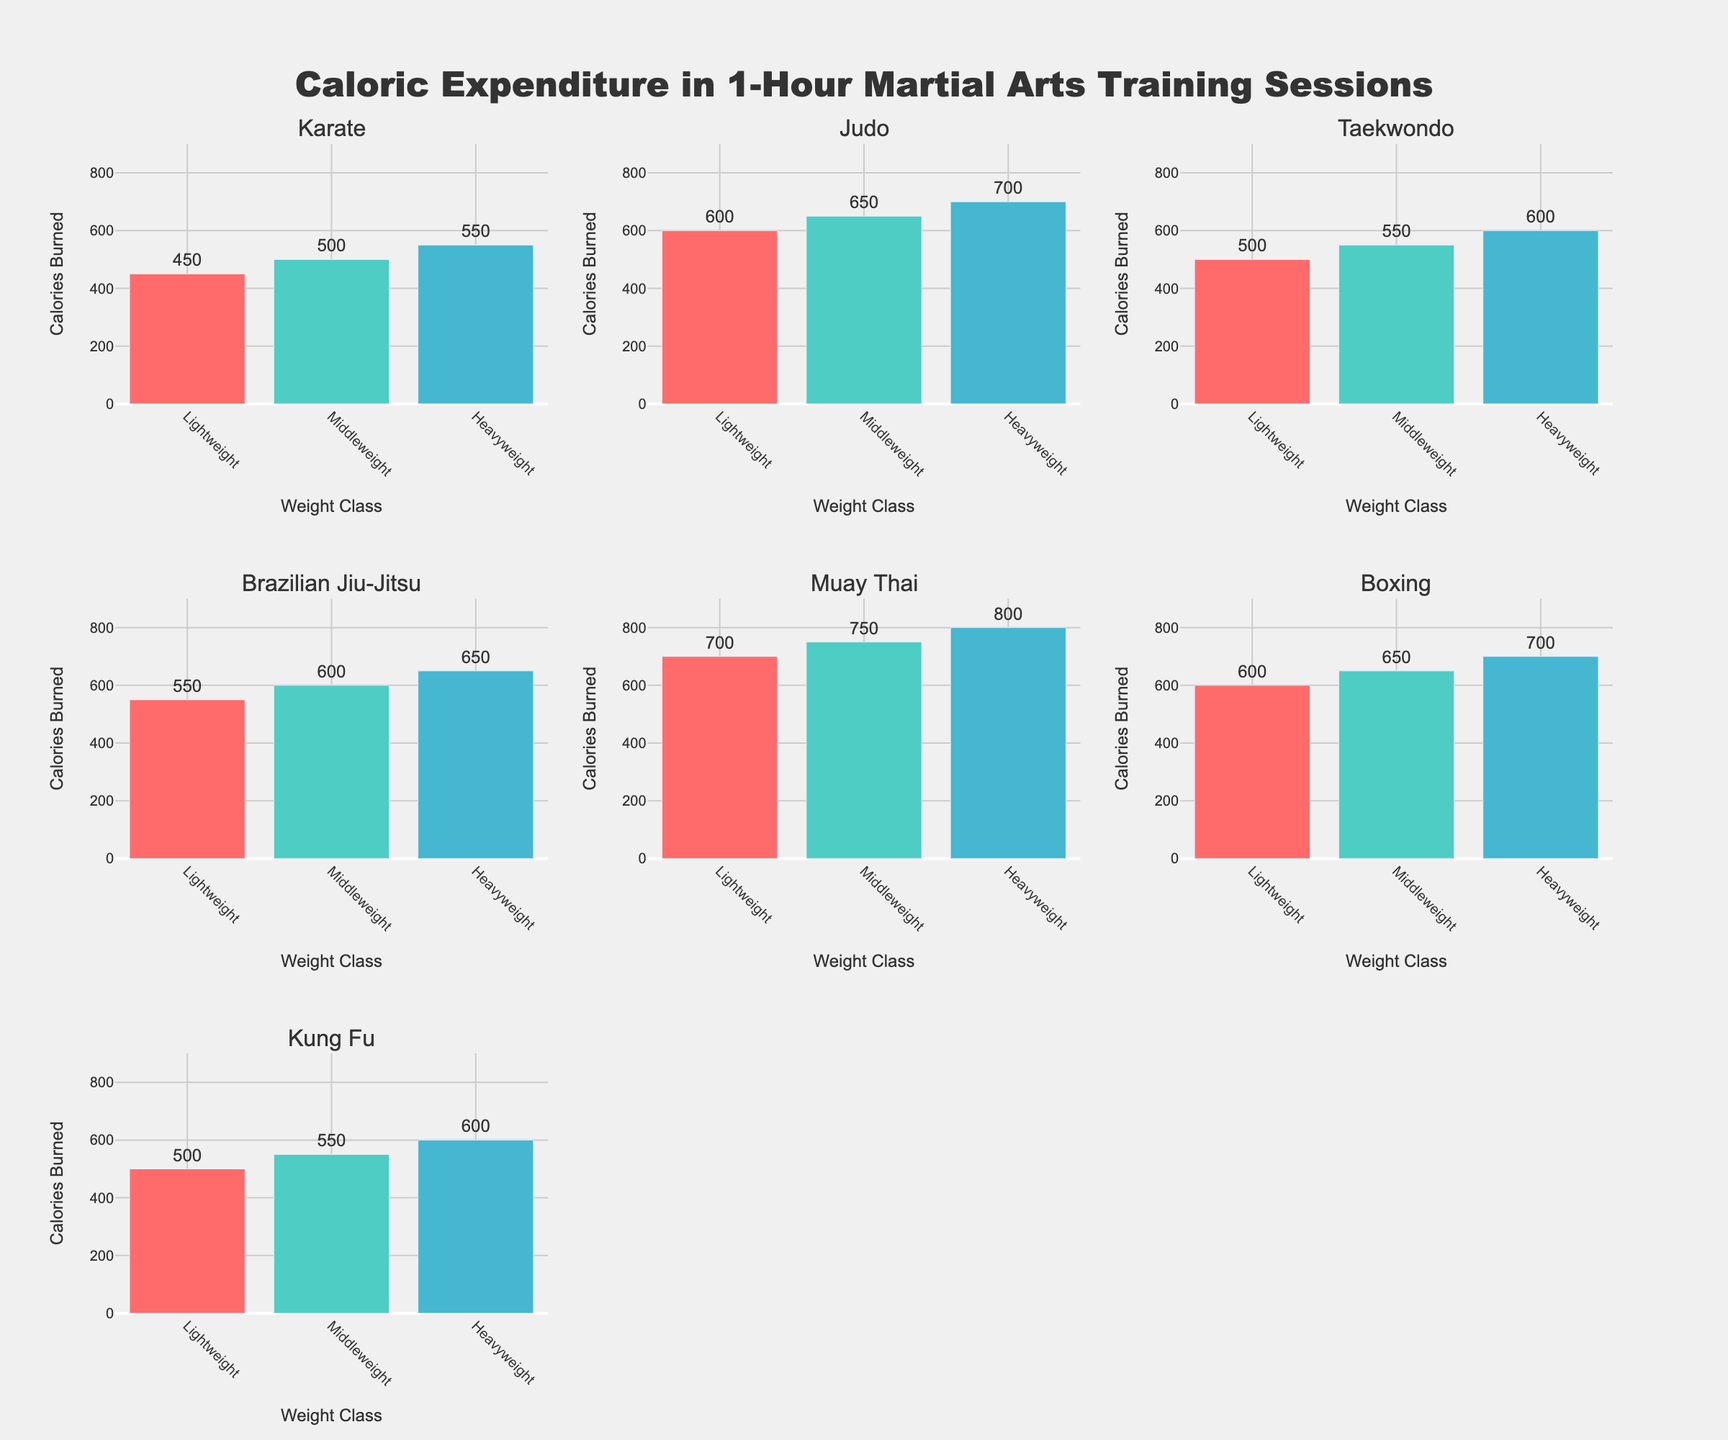What is the title of the figure? The title is prominently displayed at the top center of the figure in a larger font. It reads "Caloric Expenditure in 1-Hour Martial Arts Training Sessions".
Answer: Caloric Expenditure in 1-Hour Martial Arts Training Sessions Which weight class consistently burns the most calories across all martial arts? By comparing the calories burned in Lightweight, Middleweight, and Heavyweight categories across all subplots, you can see that the Heavyweight class consistently has the highest caloric expenditure.
Answer: Heavyweight How many caloric expenditure data points are there for Boxing? Each subplot represents one martial art and contains three bars for Lightweight, Middleweight, and Heavyweight. For Boxing, there are three data points in its subplot.
Answer: 3 What is the range of calories burned for Muay Thai across all weight classes? Muay Thai has bars for Lightweight (700 calories), Middleweight (750 calories), and Heavyweight (800 calories). The range is calculated as the difference between the highest and lowest values.
Answer: 100 calories Which martial art has the highest caloric expenditure for the Lightweight weight class? Across all subplots, compare the caloric values of the Lightweight class. Muay Thai has the highest caloric expenditure at 700 calories for the Lightweight class.
Answer: Muay Thai How does the caloric expenditure for Middleweight in Taekwondo compare to Middleweight in Kung Fu? In the Taekwondo subplot, the Middleweight bar shows 550 calories. In the Kung Fu subplot, the Middleweight bar shows 550 calories. Both are equal.
Answer: Equal What is the average caloric expenditure for Middleweight classes across all martial arts? Sum the caloric values for Middleweight in each martial art: (500 + 650 + 550 + 600 + 750 + 650 + 550). There are 7 martial arts, so the average is (4250 / 7).
Answer: 607.14 calories Which martial art shows the least caloric expenditure for the Heavyweight weight class? Compare the Heavyweight class values across all subplots. Karate and Taekwondo have the lowest values, both at 600 calories.
Answer: Karate and Taekwondo Which martial art has the smallest difference in caloric expenditure between Lightweight and Heavyweight classes? Calculate the difference for each martial art. For example, Judo: 700 - 600 = 100. Karate: 550 - 450 = 100. The lowest differences are for Karate and Judo, both at 100 calories.
Answer: Karate and Judo Which weight class contributes the most to overall caloric expenditure in Brazilian Jiu-Jitsu? In the Brazilian Jiu-Jitsu subplot, compare the bars: Lightweight (550 calories), Middleweight (600 calories), and Heavyweight (650 calories). The Heavyweight class contributes the most.
Answer: Heavyweight 